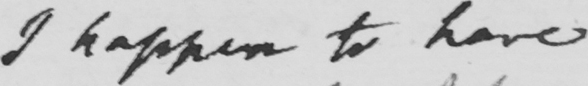Please transcribe the handwritten text in this image. I happen to have 